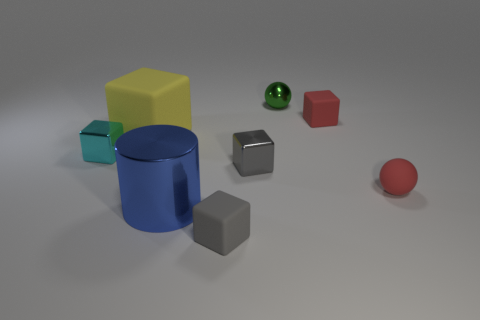Are there any other things that have the same material as the small green object?
Offer a terse response. Yes. What is the size of the other gray object that is the same shape as the gray rubber thing?
Give a very brief answer. Small. There is a cube that is on the left side of the small gray matte block and on the right side of the tiny cyan object; what is its color?
Your response must be concise. Yellow. Do the big blue cylinder and the red object behind the small cyan object have the same material?
Give a very brief answer. No. Is the number of blue cylinders to the left of the blue cylinder less than the number of large rubber objects?
Your answer should be very brief. Yes. How many other things are the same shape as the tiny cyan metallic object?
Give a very brief answer. 4. Is there any other thing of the same color as the large block?
Provide a short and direct response. No. Is the color of the big metal object the same as the rubber cube on the right side of the small metallic ball?
Provide a short and direct response. No. What number of other objects are there of the same size as the red matte sphere?
Your answer should be compact. 5. What is the size of the cube that is the same color as the tiny matte ball?
Your response must be concise. Small. 